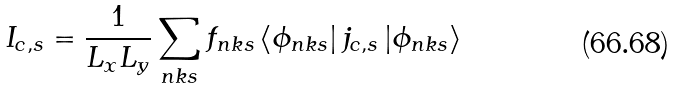<formula> <loc_0><loc_0><loc_500><loc_500>I _ { c , s } = \frac { 1 } { L _ { x } L _ { y } } \sum _ { n k s } f _ { n k s } \left \langle \phi _ { n k s } \right | j _ { c , s } \left | \phi _ { n k s } \right \rangle</formula> 